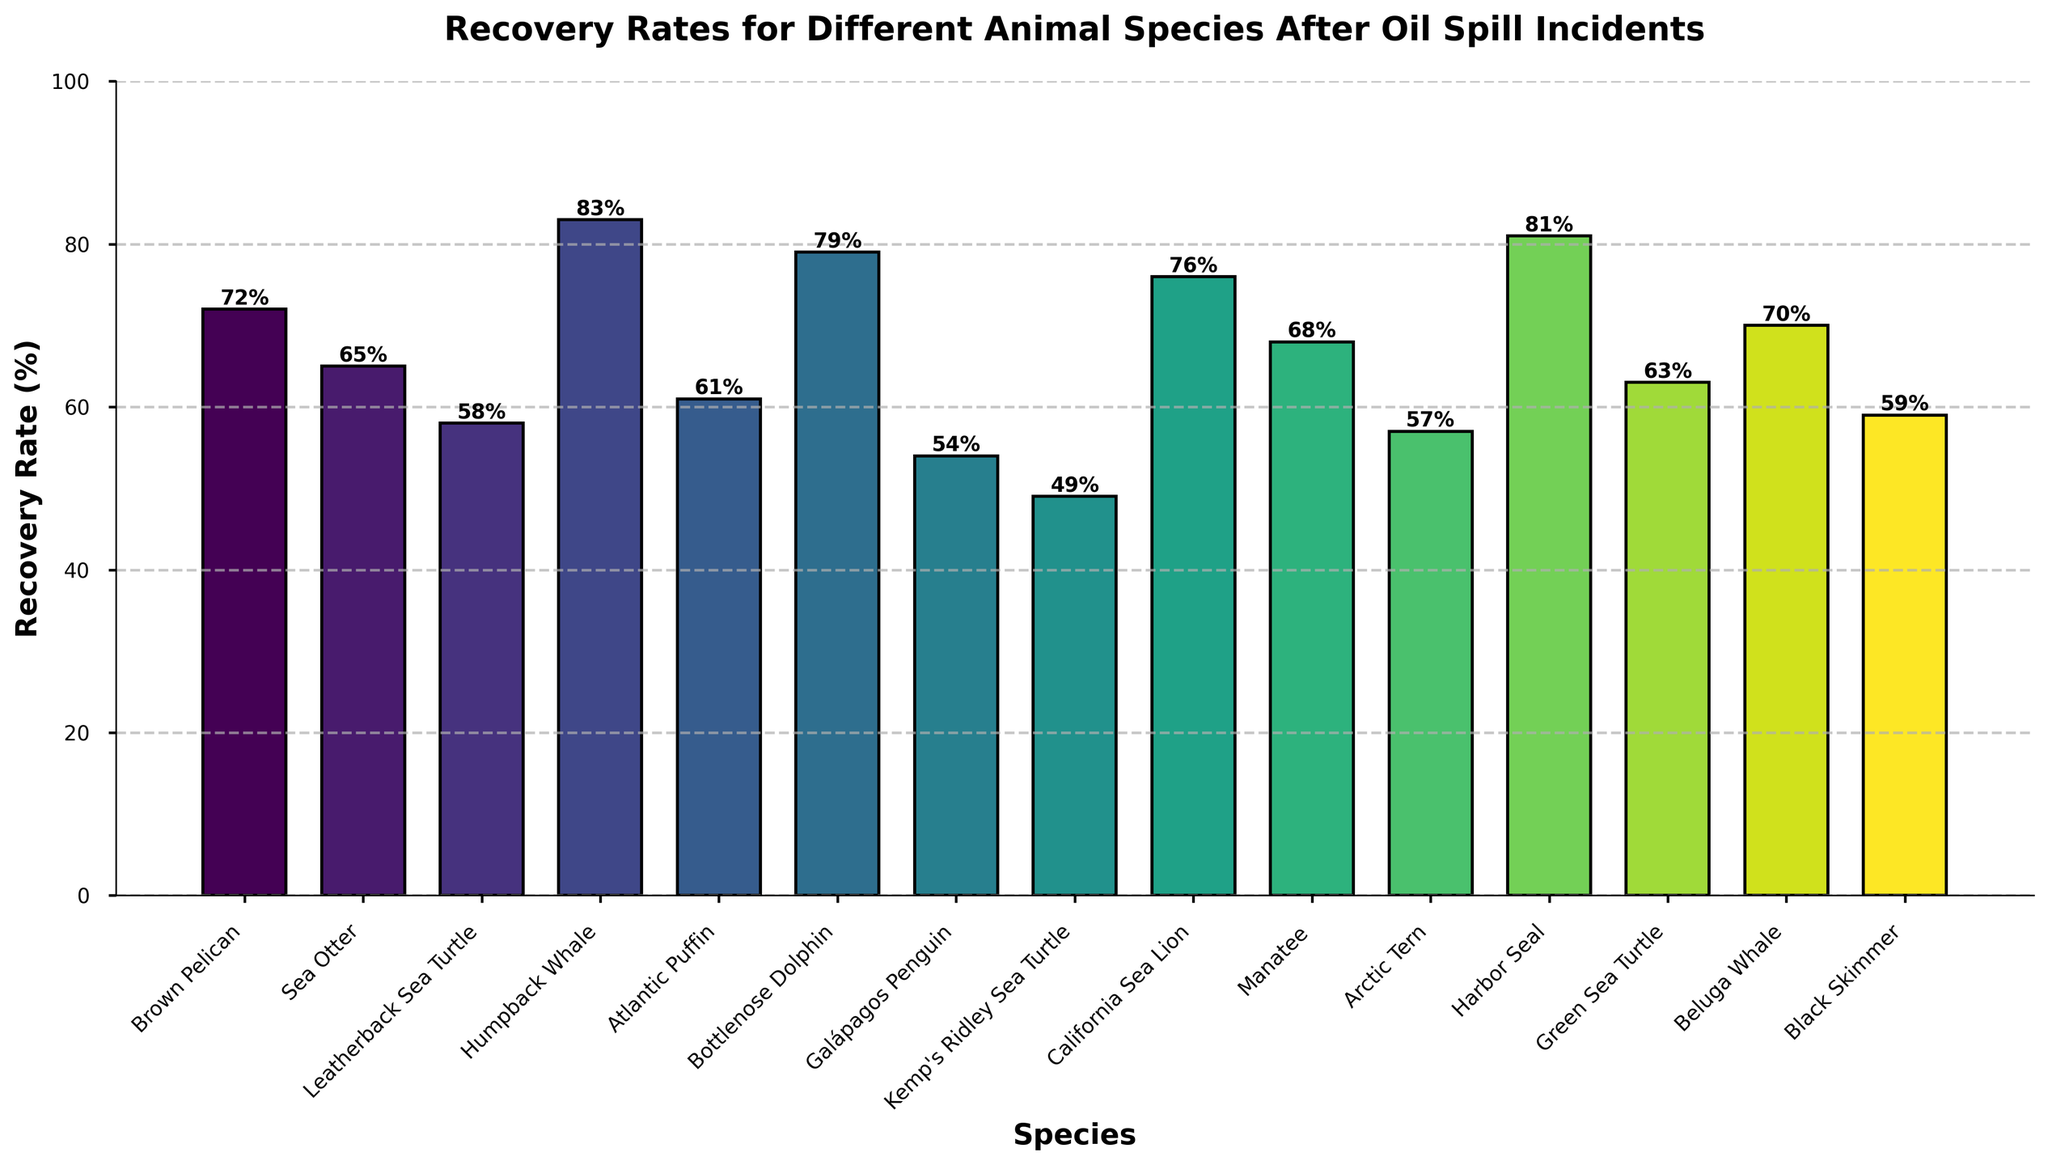Which species has the highest recovery rate? From the bar chart, find the species with the tallest bar, which indicates the highest recovery rate. The Humpback Whale has the tallest bar at 83%.
Answer: Humpback Whale Which species has the lowest recovery rate? Look for the species with the shortest bar on the chart. The Kemp's Ridley Sea Turtle has the shortest bar at 49%.
Answer: Kemp's Ridley Sea Turtle What is the difference in recovery rates between the Humpback Whale and the Galápagos Penguin? Identify the bars for Humpback Whale (83%) and Galápagos Penguin (54%) and subtract the smaller rate from the larger one. 83% - 54% = 29%.
Answer: 29% Which species have recovery rates greater than 70%? Identify all bars that are above the 70% mark. These include Brown Pelican (72%), Humpback Whale (83%), Bottlenose Dolphin (79%), California Sea Lion (76%), and Harbor Seal (81%).
Answer: Brown Pelican, Humpback Whale, Bottlenose Dolphin, California Sea Lion, Harbor Seal Which species has a recovery rate closest to the overall average recovery rate? Calculate the average recovery rate of all species and then identify the species whose recovery rate is closest to this average. The total sum of the rates is 996%, and there are 15 species, so the average is 996 / 15 = 66.4%. The recovery rate closest to 66.4% is Sea Otter (65%).
Answer: Sea Otter What is the range of the recovery rates in the chart? The range is calculated by subtracting the smallest recovery rate (Kemp's Ridley Sea Turtle at 49%) from the largest recovery rate (Humpback Whale at 83%). 83% - 49% = 34%.
Answer: 34% How many species have a recovery rate within 5% of 60%? Find recovery rates between 55% and 65%, which include Leatherback Sea Turtle (58%), Atlantic Puffin (61%), Arctic Tern (57%), Green Sea Turtle (63%), and Black Skimmer (59%). There are 5 species.
Answer: 5 Are there more species with recovery rates above or below 60%? Count the species with recovery rates above 60% and those below 60%. There are 8 species above 60% and 7 species below 60%.
Answer: Above Which species have a recovery rate of exactly 70%? Identify the bar with a height corresponding to 70%. The only species at this rate is the Beluga Whale.
Answer: Beluga Whale What percentage of species have a recovery rate of 65% or higher? Count the species with recovery rates of 65% or higher and divide by the total number of species, then multiply by 100. There are 9 species with rates of 65% or higher out of 15 total species, so the percentage is (9 / 15) * 100 = 60%.
Answer: 60% 